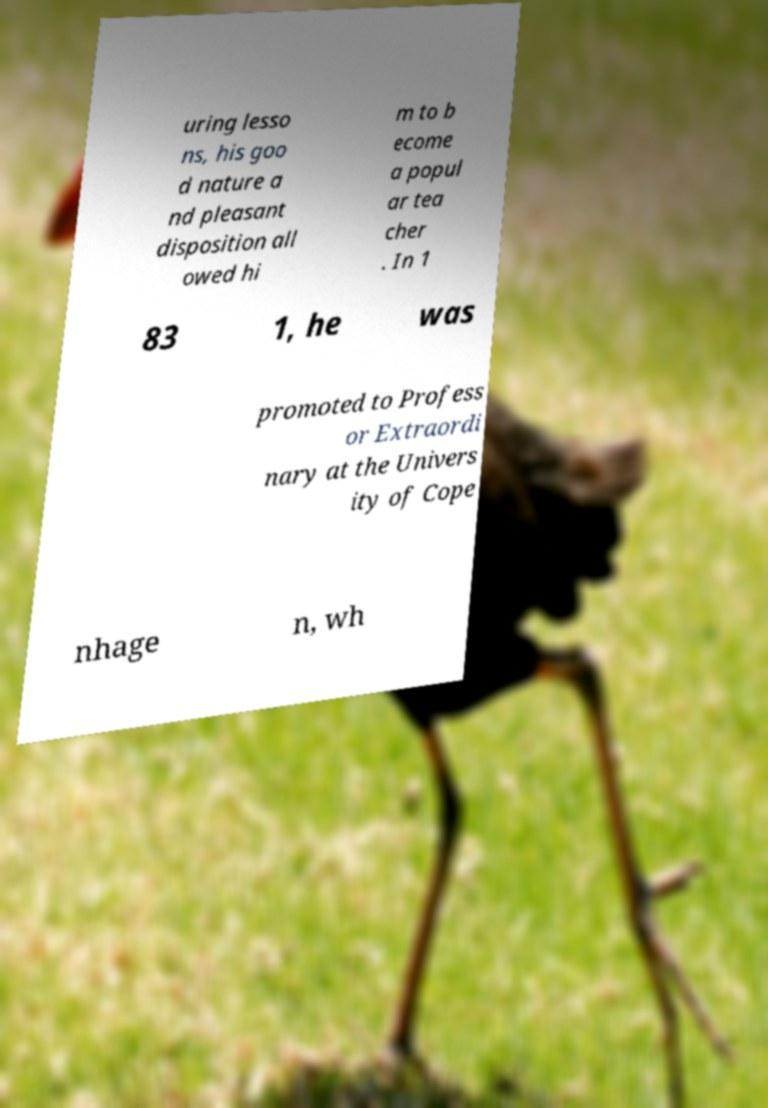Can you read and provide the text displayed in the image?This photo seems to have some interesting text. Can you extract and type it out for me? uring lesso ns, his goo d nature a nd pleasant disposition all owed hi m to b ecome a popul ar tea cher . In 1 83 1, he was promoted to Profess or Extraordi nary at the Univers ity of Cope nhage n, wh 